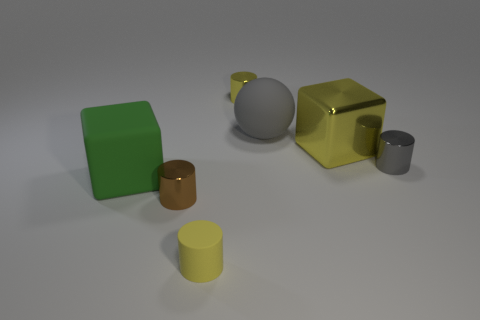Subtract all metal cylinders. How many cylinders are left? 1 Subtract all yellow cylinders. How many cylinders are left? 2 Add 1 gray rubber objects. How many objects exist? 8 Subtract all blue spheres. How many yellow cylinders are left? 2 Subtract all balls. How many objects are left? 6 Add 7 yellow cylinders. How many yellow cylinders are left? 9 Add 1 blocks. How many blocks exist? 3 Subtract 0 green cylinders. How many objects are left? 7 Subtract all yellow cylinders. Subtract all cyan balls. How many cylinders are left? 2 Subtract all tiny gray metallic cylinders. Subtract all big yellow matte spheres. How many objects are left? 6 